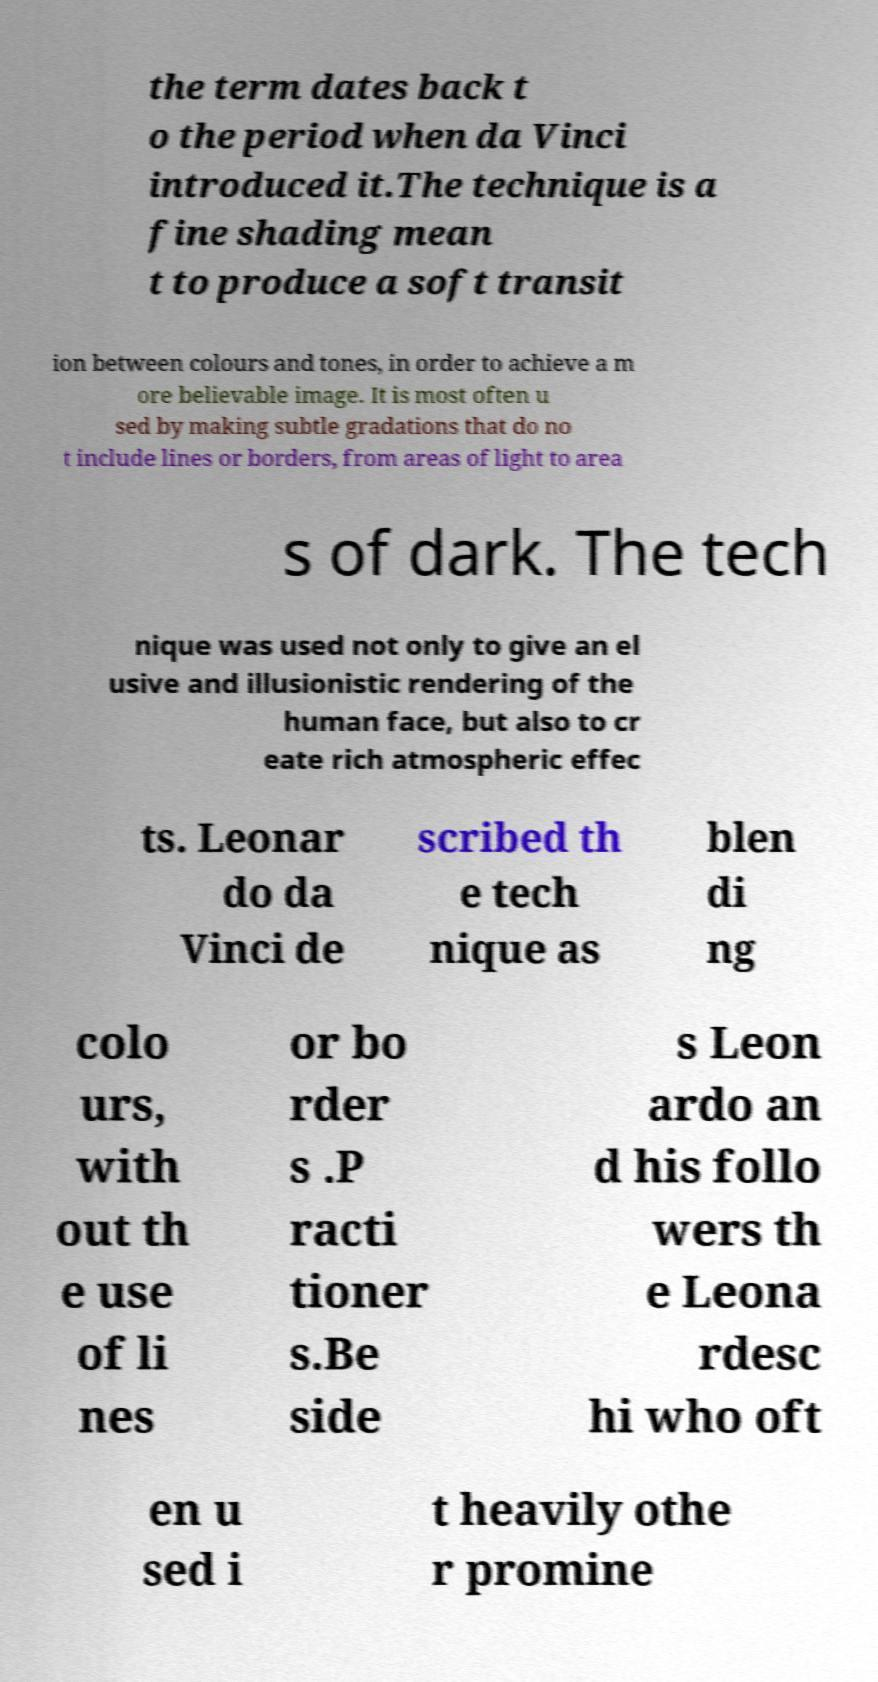Can you accurately transcribe the text from the provided image for me? the term dates back t o the period when da Vinci introduced it.The technique is a fine shading mean t to produce a soft transit ion between colours and tones, in order to achieve a m ore believable image. It is most often u sed by making subtle gradations that do no t include lines or borders, from areas of light to area s of dark. The tech nique was used not only to give an el usive and illusionistic rendering of the human face, but also to cr eate rich atmospheric effec ts. Leonar do da Vinci de scribed th e tech nique as blen di ng colo urs, with out th e use of li nes or bo rder s .P racti tioner s.Be side s Leon ardo an d his follo wers th e Leona rdesc hi who oft en u sed i t heavily othe r promine 